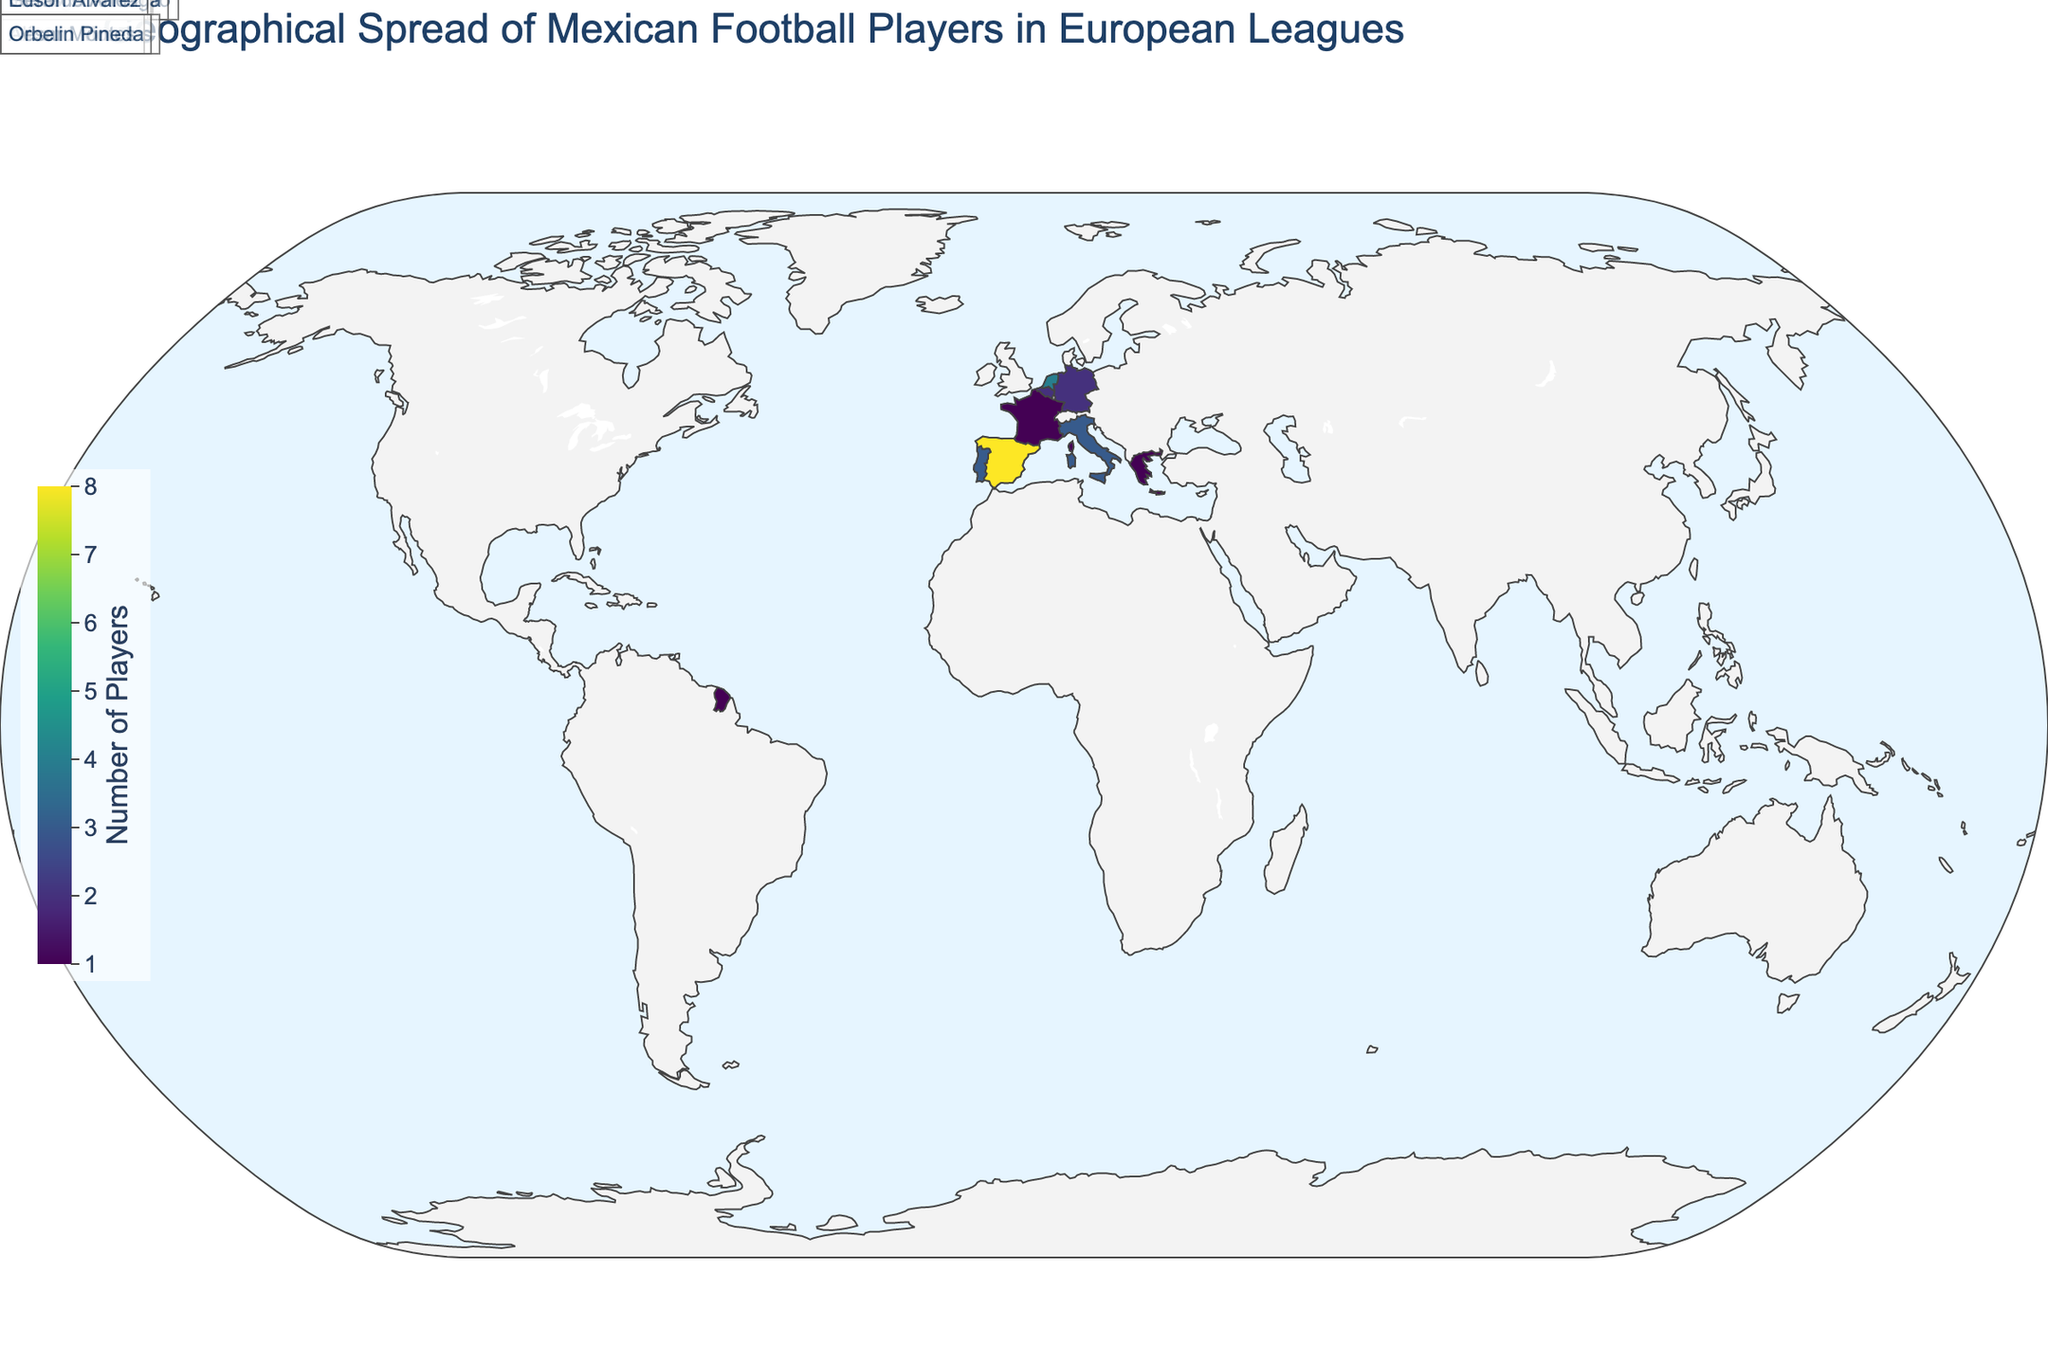What is the title of the plot? The title is prominently displayed at the top of the plot. The title provides a general overview of what the visualization is about, which helps the viewer quickly understand the subject matter of the plot.
Answer: Geographical Spread of Mexican Football Players in European Leagues Which country has the highest number of Mexican football players? By looking at the color intensity on the map and the corresponding legend which indicates the number of players, we can determine the country with the highest number of Mexican football players.
Answer: Spain How many Mexican players are in the Belgian Pro League? Locate Belgium on the map, then look at the hover information or the annotations provided to see the number of players.
Answer: 2 Who is the notable Mexican player in the Bundesliga? Hover over Germany or look at the annotation near Germany to find the name of the notable player mentioned.
Answer: Edson Alvarez How many countries have only one Mexican player? Count the number of countries on the map where the color intensity or the annotations indicate exactly one player.
Answer: 3 (Scotland, France, Greece) Which European league has the most Mexican players? Cross-reference the number of players with their respective leagues and identify the league with the highest count.
Answer: La Liga Which countries have fewer Mexican players than the Netherlands? Compare the number of players in the Netherlands (4) with other countries and identify those having fewer players.
Answer: Italy, Portugal, Belgium, Germany, Scotland, France, Greece How many notable players are named in the plot? Count the annotations with the names of notable players. There should be one for each country listed.
Answer: 10 